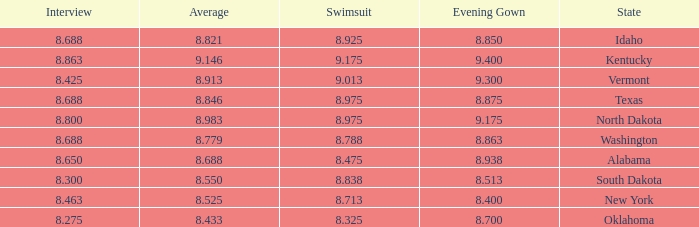Who had the lowest interview score from South Dakota with an evening gown less than 8.513? None. 